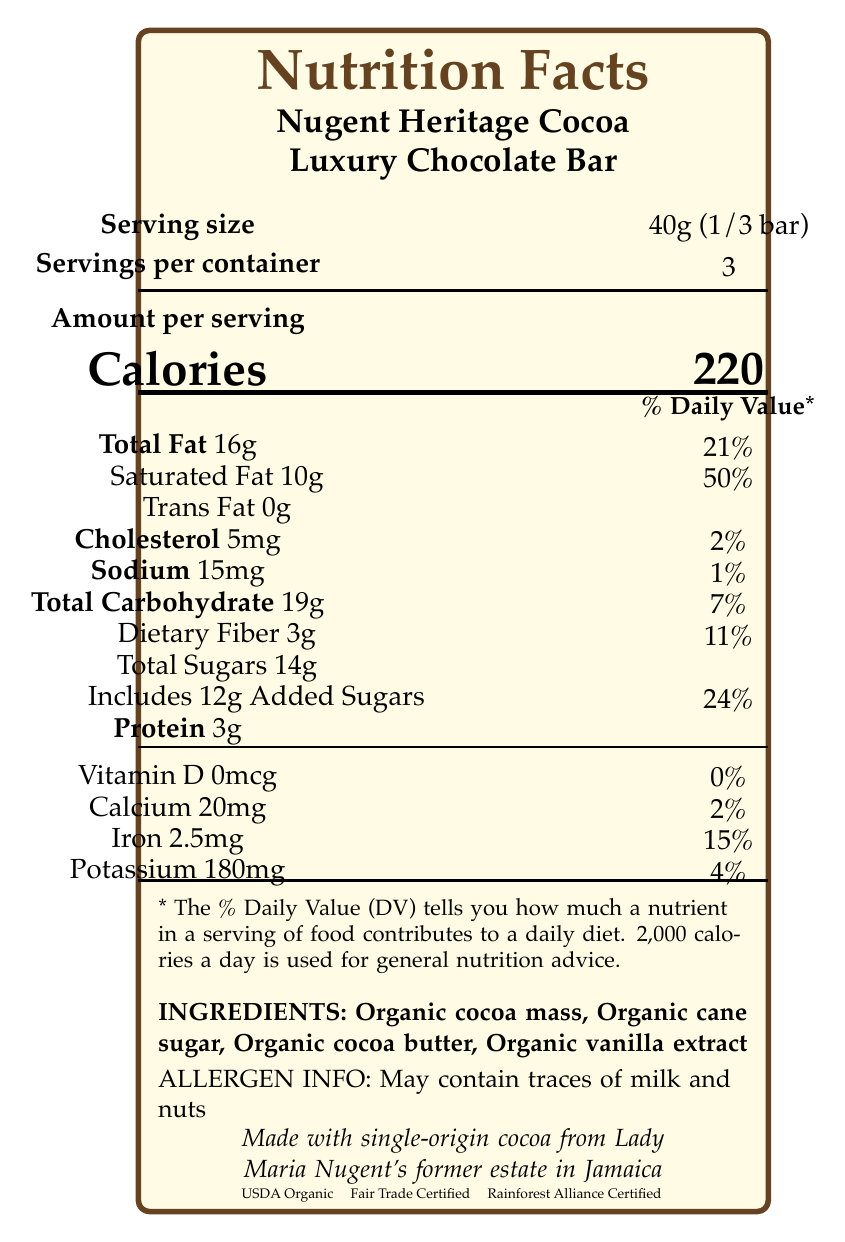what is the serving size of the Nugent Heritage Cocoa Luxury Chocolate Bar? The serving size is mentioned as "40g (1/3 bar)" in the document.
Answer: 40g (1/3 bar) how many servings per container are there? The document states that there are 3 servings per container.
Answer: 3 how many calories are in one serving of the chocolate bar? The document specifies that each serving contains 220 calories.
Answer: 220 what is the total fat content per serving? The total fat content per serving is listed as 16g.
Answer: 16g how much saturated fat is there per serving, and what percentage of the daily value does it represent? The document shows that there are 10g of saturated fat per serving, which represents 50% of the daily value.
Answer: 10g, 50% how much cholesterol is found in one serving? A. 3mg B. 5mg C. 7mg D. 9mg The document states that there are 5mg of cholesterol per serving.
Answer: B. 5mg what is the sodium content per serving in this chocolate bar? The sodium content per serving is 15mg, as mentioned in the document.
Answer: 15mg how much protein does one serving of the chocolate bar contain? The protein content per serving is 3g.
Answer: 3g which ingredients are included in the Nugent Heritage Cocoa Luxury Chocolate Bar? A. Organic cocoa mass, Organic cane sugar, Organic vanilla extract B. Organic cocoa mass, Organic cane sugar, Organic cocoa butter, Organic vanilla extract C. Organic cocoa butter, Organic cane sugar, Organic vanilla extract The document lists the ingredients as "Organic cocoa mass, Organic cane sugar, Organic cocoa butter, Organic vanilla extract".
Answer: B. Organic cocoa mass, Organic cane sugar, Organic cocoa butter, Organic vanilla extract are there any potential allergens in the chocolate bar? The document indicates that the chocolate bar may contain traces of milk and nuts.
Answer: Yes does the product contain any added sugars? The document specifies that the product includes 12g of added sugars per serving.
Answer: Yes what certifications does the Nugent Heritage Cocoa Luxury Chocolate Bar have? The certifications listed in the document are USDA Organic, Fair Trade Certified, and Rainforest Alliance Certified.
Answer: USDA Organic, Fair Trade Certified, Rainforest Alliance Certified describe the main information presented in the document. The detailed description includes nutritional information, ingredient list, allergen warning, product certifications, and its unique historical and origin context related to Lady Maria Nugent.
Answer: The document provides Nutrition Facts for the Nugent Heritage Cocoa Luxury Chocolate Bar, including serving size, calories, fat content, cholesterol, sodium, carbohydrates, protein, and various vitamins and minerals. It lists the ingredients and highlights potential allergens. The document also mentions the product's certifications and its origin statement, indicating that the cocoa is sourced from Lady Maria Nugent's former estate in Jamaica. what is the recommended daily calorie intake used for general nutrition advice according to the document? The document notes that 2,000 calories a day is used for general nutrition advice.
Answer: 2,000 calories how much iron is there per serving, and what percentage of the daily value does it represent? The iron content per serving is 2.5mg, which represents 15% of the daily value.
Answer: 2.5mg, 15% does the chocolate bar contain any vitamin D? The document specifies that there is 0mcg of vitamin D per serving, which is 0% of the daily value.
Answer: No what was Lady Maria Nugent's role and historical significance mentioned in the document? The document includes a historical note about Lady Maria Nugent, mentioning she was the wife of George Nugent, Governor of Jamaica from 1801-1806, and her diary provides insights into plantation life and cocoa cultivation during that era. However, the specific role and detailed historical significance cannot be fully inferred solely from this document.
Answer: Cannot be determined 